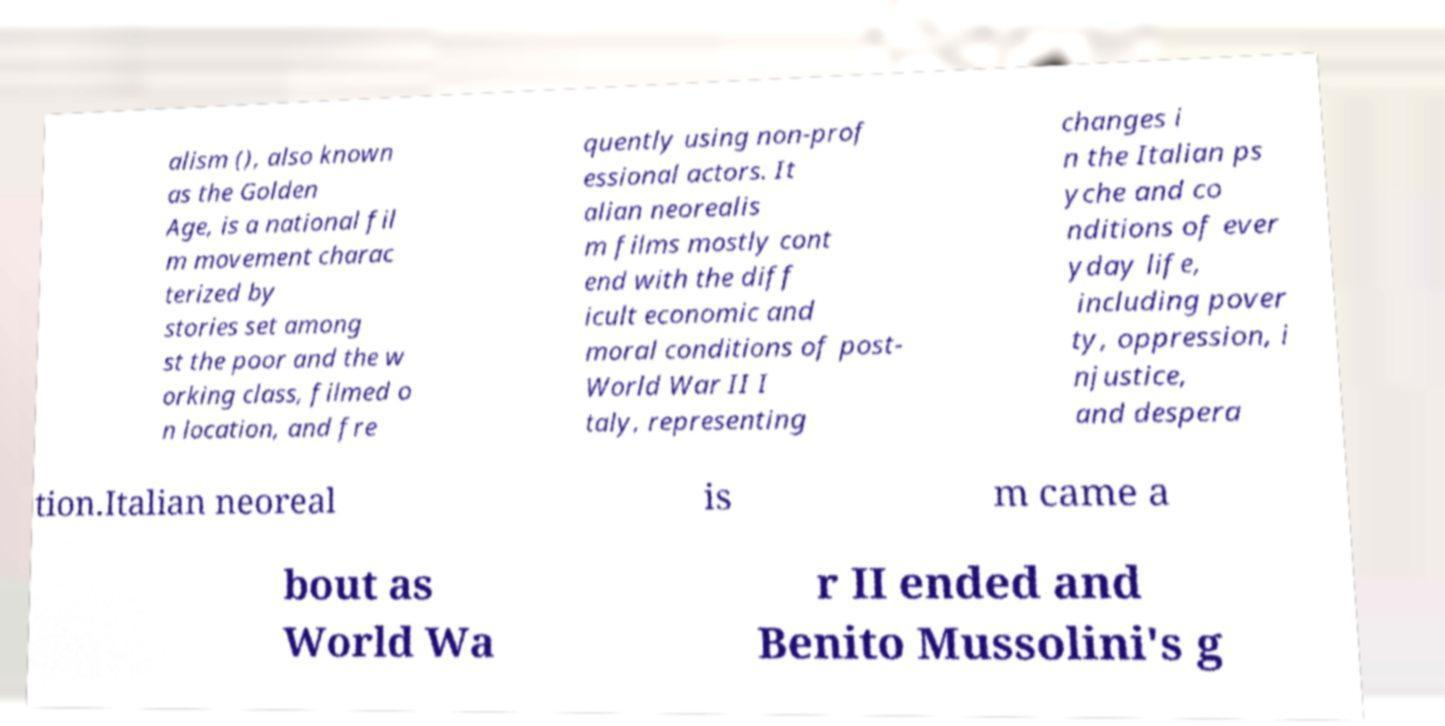Could you assist in decoding the text presented in this image and type it out clearly? alism (), also known as the Golden Age, is a national fil m movement charac terized by stories set among st the poor and the w orking class, filmed o n location, and fre quently using non-prof essional actors. It alian neorealis m films mostly cont end with the diff icult economic and moral conditions of post- World War II I taly, representing changes i n the Italian ps yche and co nditions of ever yday life, including pover ty, oppression, i njustice, and despera tion.Italian neoreal is m came a bout as World Wa r II ended and Benito Mussolini's g 